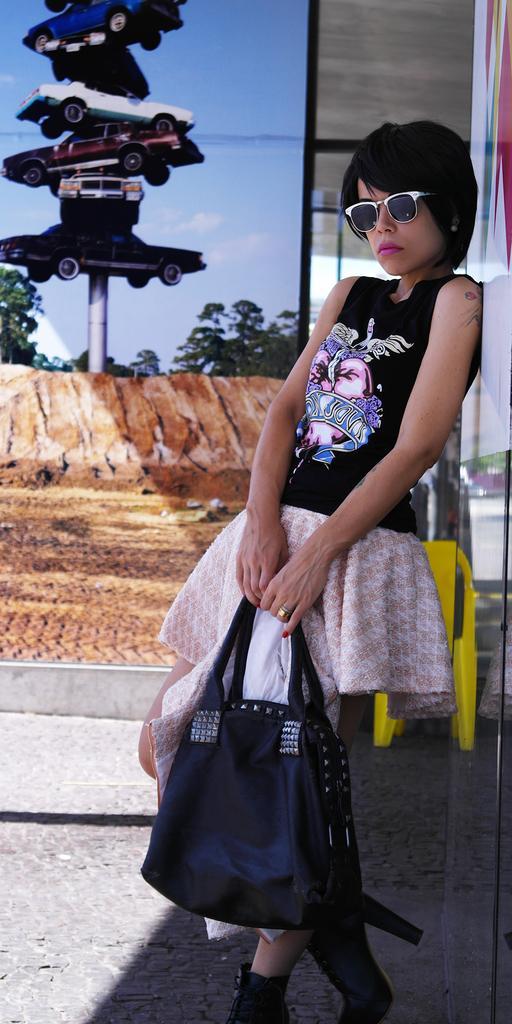Please provide a concise description of this image. This woman is highlighted in this picture. This woman wore black dress, goggles and holding a bag. On pole there are cars. Far there are number of trees. This is a poster on wall. 